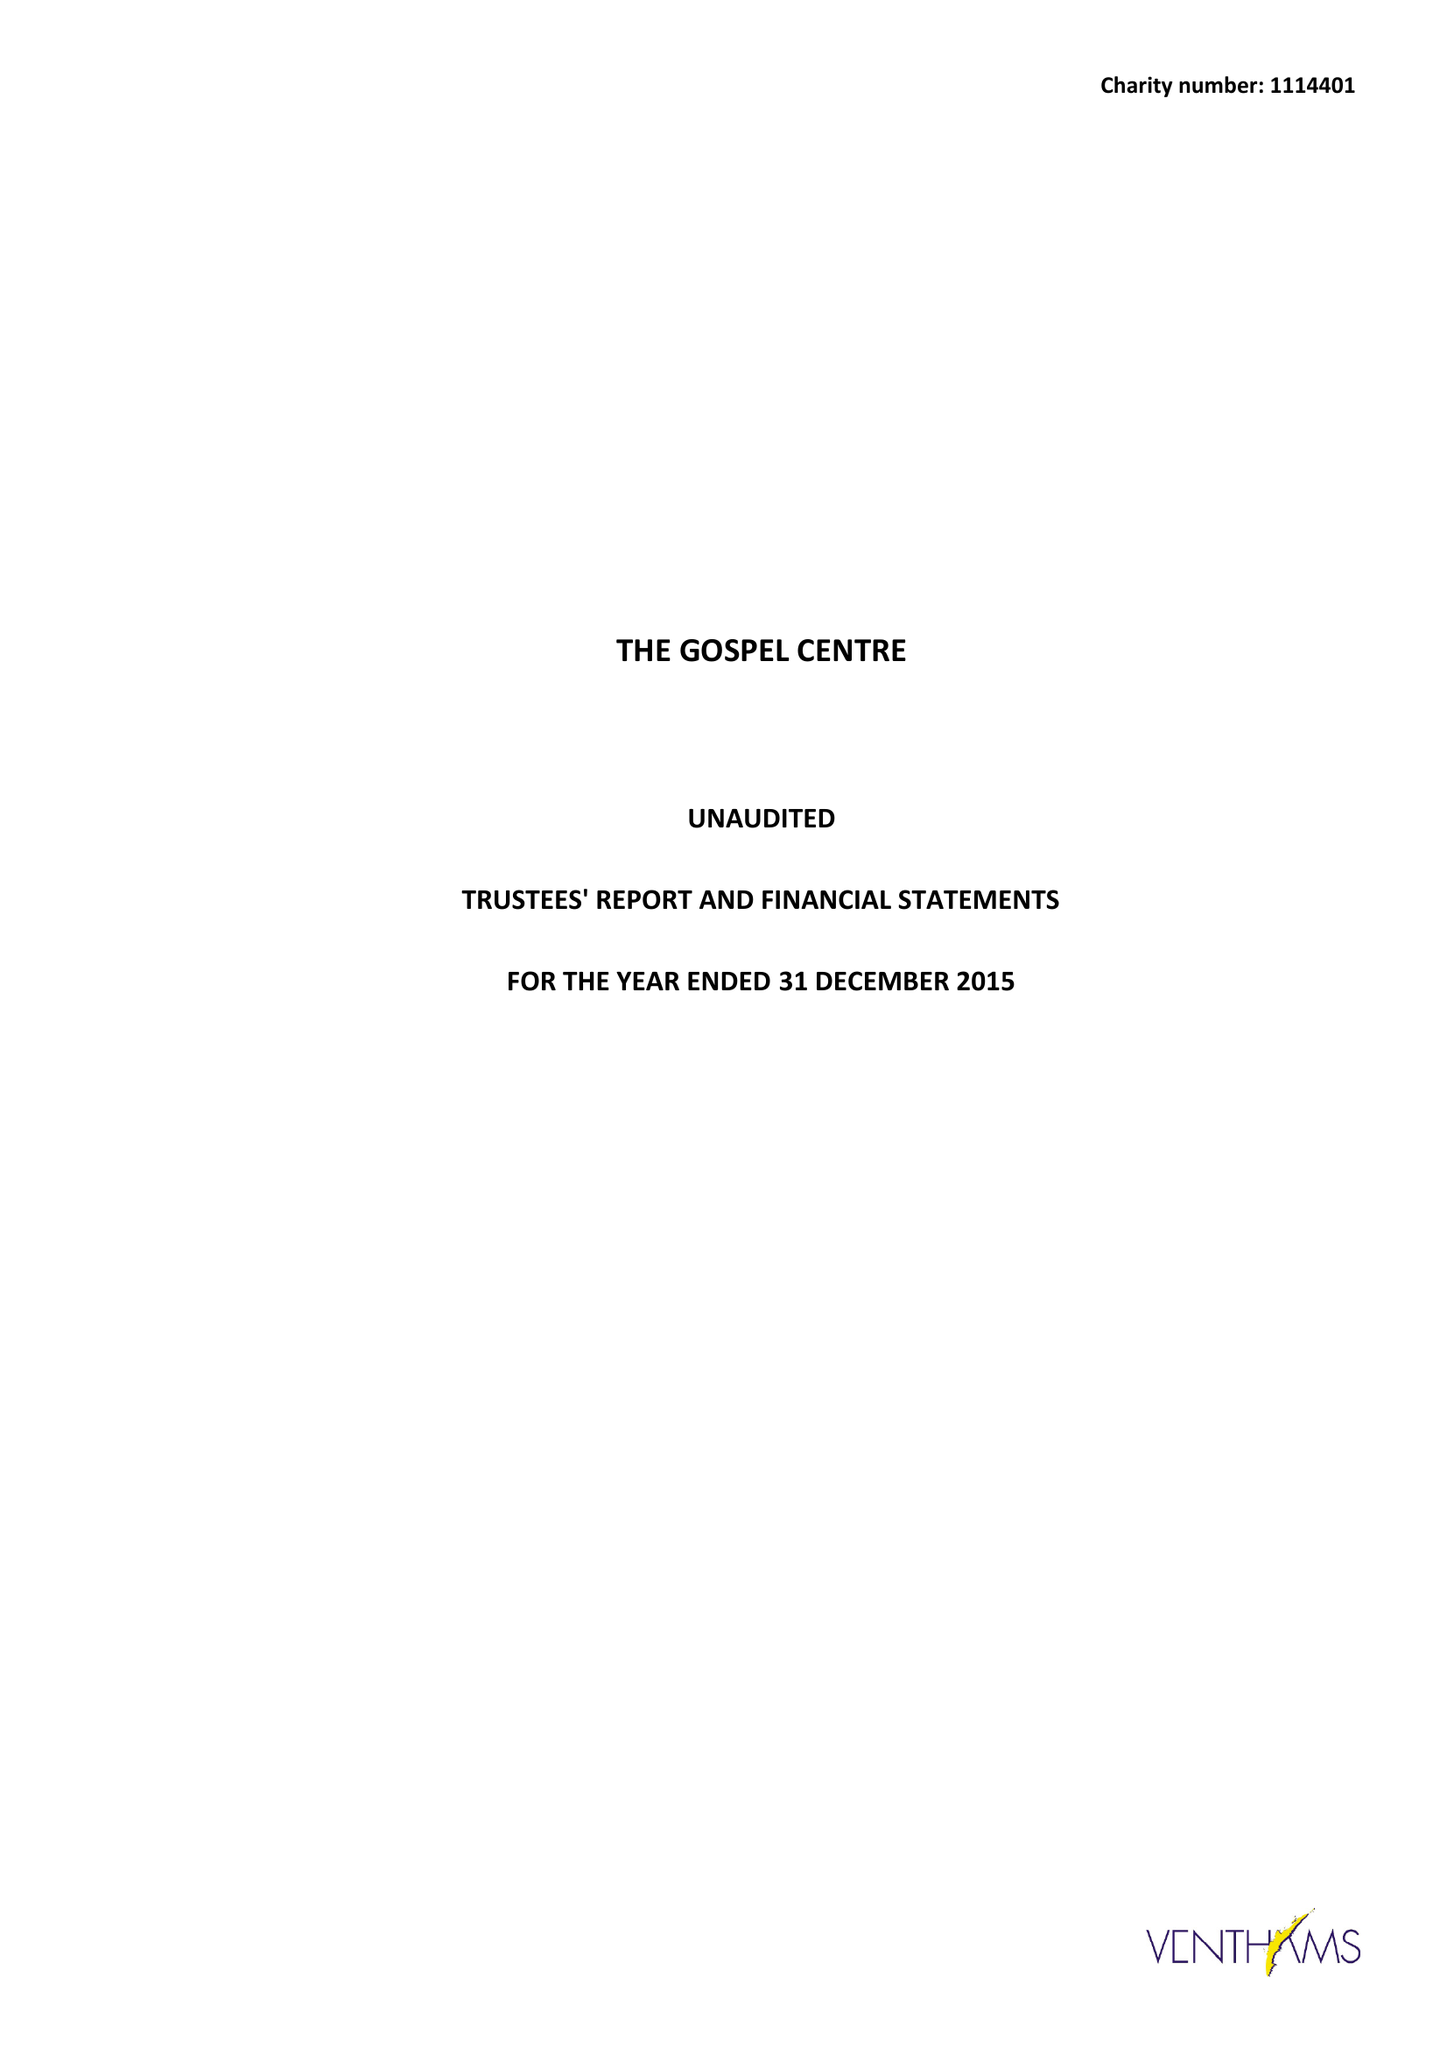What is the value for the address__post_town?
Answer the question using a single word or phrase. LONDON 